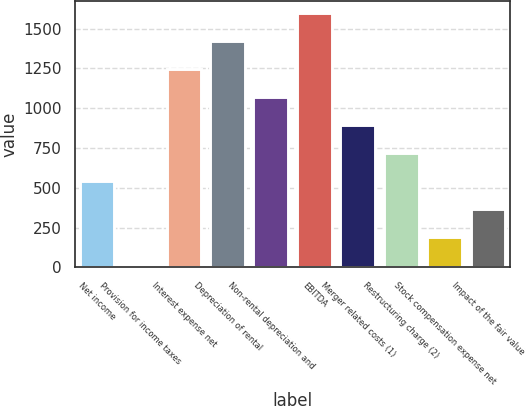Convert chart to OTSL. <chart><loc_0><loc_0><loc_500><loc_500><bar_chart><fcel>Net income<fcel>Provision for income taxes<fcel>Interest expense net<fcel>Depreciation of rental<fcel>Non-rental depreciation and<fcel>EBITDA<fcel>Merger related costs (1)<fcel>Restructuring charge (2)<fcel>Stock compensation expense net<fcel>Impact of the fair value<nl><fcel>540.7<fcel>13<fcel>1244.3<fcel>1420.2<fcel>1068.4<fcel>1596.1<fcel>892.5<fcel>716.6<fcel>188.9<fcel>364.8<nl></chart> 